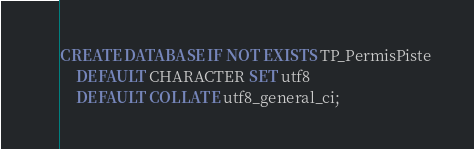<code> <loc_0><loc_0><loc_500><loc_500><_SQL_>CREATE DATABASE IF NOT EXISTS TP_PermisPiste
	DEFAULT CHARACTER SET utf8
	DEFAULT COLLATE utf8_general_ci;</code> 